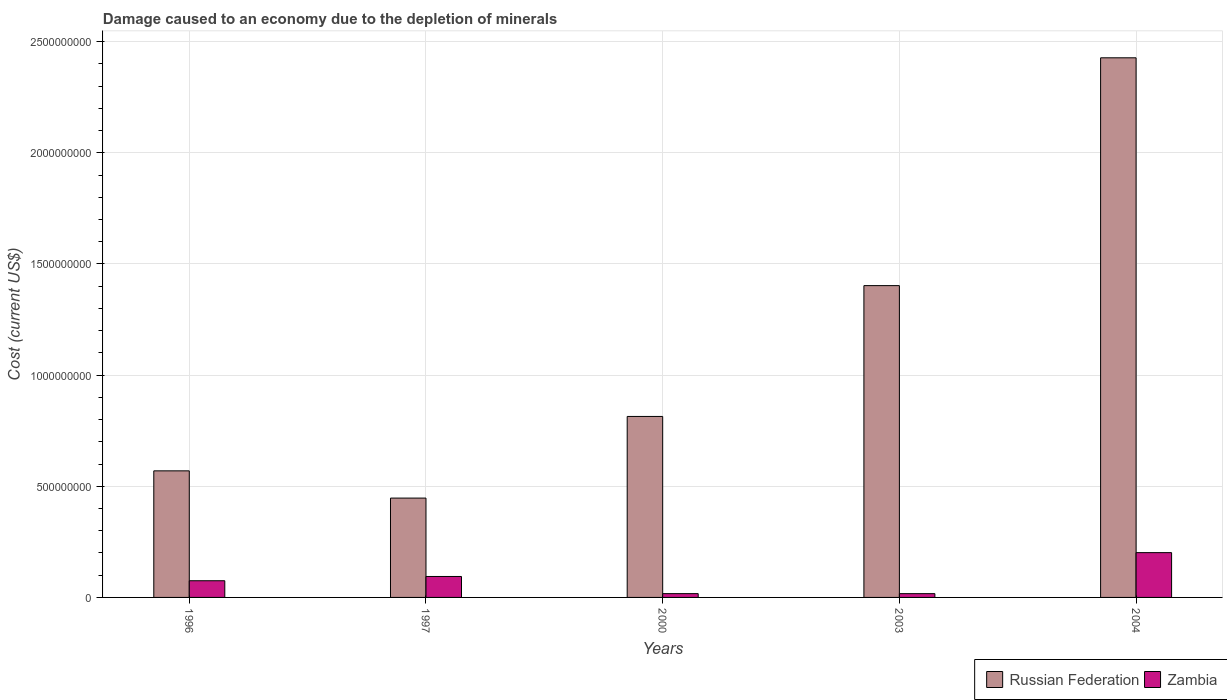How many groups of bars are there?
Offer a terse response. 5. Are the number of bars per tick equal to the number of legend labels?
Offer a terse response. Yes. How many bars are there on the 4th tick from the right?
Provide a succinct answer. 2. What is the label of the 2nd group of bars from the left?
Make the answer very short. 1997. What is the cost of damage caused due to the depletion of minerals in Russian Federation in 2004?
Make the answer very short. 2.43e+09. Across all years, what is the maximum cost of damage caused due to the depletion of minerals in Russian Federation?
Give a very brief answer. 2.43e+09. Across all years, what is the minimum cost of damage caused due to the depletion of minerals in Zambia?
Your answer should be very brief. 1.70e+07. In which year was the cost of damage caused due to the depletion of minerals in Zambia maximum?
Ensure brevity in your answer.  2004. What is the total cost of damage caused due to the depletion of minerals in Russian Federation in the graph?
Ensure brevity in your answer.  5.66e+09. What is the difference between the cost of damage caused due to the depletion of minerals in Zambia in 2003 and that in 2004?
Offer a terse response. -1.85e+08. What is the difference between the cost of damage caused due to the depletion of minerals in Russian Federation in 2000 and the cost of damage caused due to the depletion of minerals in Zambia in 2004?
Provide a succinct answer. 6.13e+08. What is the average cost of damage caused due to the depletion of minerals in Zambia per year?
Offer a terse response. 8.10e+07. In the year 2003, what is the difference between the cost of damage caused due to the depletion of minerals in Russian Federation and cost of damage caused due to the depletion of minerals in Zambia?
Your answer should be very brief. 1.39e+09. What is the ratio of the cost of damage caused due to the depletion of minerals in Zambia in 1996 to that in 1997?
Provide a succinct answer. 0.8. Is the difference between the cost of damage caused due to the depletion of minerals in Russian Federation in 1996 and 2003 greater than the difference between the cost of damage caused due to the depletion of minerals in Zambia in 1996 and 2003?
Offer a terse response. No. What is the difference between the highest and the second highest cost of damage caused due to the depletion of minerals in Zambia?
Your response must be concise. 1.07e+08. What is the difference between the highest and the lowest cost of damage caused due to the depletion of minerals in Russian Federation?
Your answer should be compact. 1.98e+09. What does the 2nd bar from the left in 2004 represents?
Make the answer very short. Zambia. What does the 2nd bar from the right in 1997 represents?
Give a very brief answer. Russian Federation. How many bars are there?
Ensure brevity in your answer.  10. How many years are there in the graph?
Your answer should be very brief. 5. What is the difference between two consecutive major ticks on the Y-axis?
Your answer should be compact. 5.00e+08. Are the values on the major ticks of Y-axis written in scientific E-notation?
Give a very brief answer. No. Does the graph contain any zero values?
Your answer should be very brief. No. Does the graph contain grids?
Your answer should be very brief. Yes. How many legend labels are there?
Offer a very short reply. 2. What is the title of the graph?
Offer a terse response. Damage caused to an economy due to the depletion of minerals. Does "Jamaica" appear as one of the legend labels in the graph?
Your answer should be very brief. No. What is the label or title of the X-axis?
Give a very brief answer. Years. What is the label or title of the Y-axis?
Your answer should be compact. Cost (current US$). What is the Cost (current US$) in Russian Federation in 1996?
Your answer should be very brief. 5.69e+08. What is the Cost (current US$) of Zambia in 1996?
Make the answer very short. 7.51e+07. What is the Cost (current US$) in Russian Federation in 1997?
Your answer should be compact. 4.47e+08. What is the Cost (current US$) in Zambia in 1997?
Offer a terse response. 9.42e+07. What is the Cost (current US$) of Russian Federation in 2000?
Your response must be concise. 8.14e+08. What is the Cost (current US$) of Zambia in 2000?
Provide a short and direct response. 1.70e+07. What is the Cost (current US$) of Russian Federation in 2003?
Make the answer very short. 1.40e+09. What is the Cost (current US$) of Zambia in 2003?
Offer a terse response. 1.70e+07. What is the Cost (current US$) in Russian Federation in 2004?
Your answer should be very brief. 2.43e+09. What is the Cost (current US$) in Zambia in 2004?
Provide a succinct answer. 2.02e+08. Across all years, what is the maximum Cost (current US$) in Russian Federation?
Make the answer very short. 2.43e+09. Across all years, what is the maximum Cost (current US$) in Zambia?
Make the answer very short. 2.02e+08. Across all years, what is the minimum Cost (current US$) in Russian Federation?
Give a very brief answer. 4.47e+08. Across all years, what is the minimum Cost (current US$) of Zambia?
Ensure brevity in your answer.  1.70e+07. What is the total Cost (current US$) of Russian Federation in the graph?
Ensure brevity in your answer.  5.66e+09. What is the total Cost (current US$) of Zambia in the graph?
Give a very brief answer. 4.05e+08. What is the difference between the Cost (current US$) of Russian Federation in 1996 and that in 1997?
Keep it short and to the point. 1.22e+08. What is the difference between the Cost (current US$) in Zambia in 1996 and that in 1997?
Give a very brief answer. -1.92e+07. What is the difference between the Cost (current US$) of Russian Federation in 1996 and that in 2000?
Your answer should be very brief. -2.45e+08. What is the difference between the Cost (current US$) in Zambia in 1996 and that in 2000?
Provide a short and direct response. 5.80e+07. What is the difference between the Cost (current US$) in Russian Federation in 1996 and that in 2003?
Your response must be concise. -8.33e+08. What is the difference between the Cost (current US$) in Zambia in 1996 and that in 2003?
Make the answer very short. 5.80e+07. What is the difference between the Cost (current US$) of Russian Federation in 1996 and that in 2004?
Ensure brevity in your answer.  -1.86e+09. What is the difference between the Cost (current US$) of Zambia in 1996 and that in 2004?
Offer a very short reply. -1.26e+08. What is the difference between the Cost (current US$) in Russian Federation in 1997 and that in 2000?
Keep it short and to the point. -3.67e+08. What is the difference between the Cost (current US$) of Zambia in 1997 and that in 2000?
Offer a very short reply. 7.72e+07. What is the difference between the Cost (current US$) in Russian Federation in 1997 and that in 2003?
Your answer should be compact. -9.56e+08. What is the difference between the Cost (current US$) of Zambia in 1997 and that in 2003?
Provide a succinct answer. 7.72e+07. What is the difference between the Cost (current US$) of Russian Federation in 1997 and that in 2004?
Your answer should be very brief. -1.98e+09. What is the difference between the Cost (current US$) of Zambia in 1997 and that in 2004?
Your answer should be compact. -1.07e+08. What is the difference between the Cost (current US$) of Russian Federation in 2000 and that in 2003?
Ensure brevity in your answer.  -5.88e+08. What is the difference between the Cost (current US$) in Zambia in 2000 and that in 2003?
Offer a very short reply. 1.23e+04. What is the difference between the Cost (current US$) of Russian Federation in 2000 and that in 2004?
Your answer should be very brief. -1.61e+09. What is the difference between the Cost (current US$) in Zambia in 2000 and that in 2004?
Keep it short and to the point. -1.84e+08. What is the difference between the Cost (current US$) of Russian Federation in 2003 and that in 2004?
Keep it short and to the point. -1.02e+09. What is the difference between the Cost (current US$) of Zambia in 2003 and that in 2004?
Offer a terse response. -1.85e+08. What is the difference between the Cost (current US$) of Russian Federation in 1996 and the Cost (current US$) of Zambia in 1997?
Your response must be concise. 4.75e+08. What is the difference between the Cost (current US$) of Russian Federation in 1996 and the Cost (current US$) of Zambia in 2000?
Give a very brief answer. 5.52e+08. What is the difference between the Cost (current US$) of Russian Federation in 1996 and the Cost (current US$) of Zambia in 2003?
Provide a succinct answer. 5.52e+08. What is the difference between the Cost (current US$) in Russian Federation in 1996 and the Cost (current US$) in Zambia in 2004?
Give a very brief answer. 3.68e+08. What is the difference between the Cost (current US$) of Russian Federation in 1997 and the Cost (current US$) of Zambia in 2000?
Keep it short and to the point. 4.30e+08. What is the difference between the Cost (current US$) of Russian Federation in 1997 and the Cost (current US$) of Zambia in 2003?
Offer a terse response. 4.30e+08. What is the difference between the Cost (current US$) in Russian Federation in 1997 and the Cost (current US$) in Zambia in 2004?
Keep it short and to the point. 2.45e+08. What is the difference between the Cost (current US$) in Russian Federation in 2000 and the Cost (current US$) in Zambia in 2003?
Provide a succinct answer. 7.97e+08. What is the difference between the Cost (current US$) of Russian Federation in 2000 and the Cost (current US$) of Zambia in 2004?
Your answer should be compact. 6.13e+08. What is the difference between the Cost (current US$) of Russian Federation in 2003 and the Cost (current US$) of Zambia in 2004?
Make the answer very short. 1.20e+09. What is the average Cost (current US$) of Russian Federation per year?
Make the answer very short. 1.13e+09. What is the average Cost (current US$) in Zambia per year?
Make the answer very short. 8.10e+07. In the year 1996, what is the difference between the Cost (current US$) of Russian Federation and Cost (current US$) of Zambia?
Give a very brief answer. 4.94e+08. In the year 1997, what is the difference between the Cost (current US$) of Russian Federation and Cost (current US$) of Zambia?
Offer a very short reply. 3.53e+08. In the year 2000, what is the difference between the Cost (current US$) of Russian Federation and Cost (current US$) of Zambia?
Keep it short and to the point. 7.97e+08. In the year 2003, what is the difference between the Cost (current US$) of Russian Federation and Cost (current US$) of Zambia?
Give a very brief answer. 1.39e+09. In the year 2004, what is the difference between the Cost (current US$) in Russian Federation and Cost (current US$) in Zambia?
Provide a short and direct response. 2.23e+09. What is the ratio of the Cost (current US$) in Russian Federation in 1996 to that in 1997?
Ensure brevity in your answer.  1.27. What is the ratio of the Cost (current US$) of Zambia in 1996 to that in 1997?
Ensure brevity in your answer.  0.8. What is the ratio of the Cost (current US$) of Russian Federation in 1996 to that in 2000?
Provide a short and direct response. 0.7. What is the ratio of the Cost (current US$) in Zambia in 1996 to that in 2000?
Ensure brevity in your answer.  4.4. What is the ratio of the Cost (current US$) of Russian Federation in 1996 to that in 2003?
Your response must be concise. 0.41. What is the ratio of the Cost (current US$) in Zambia in 1996 to that in 2003?
Keep it short and to the point. 4.41. What is the ratio of the Cost (current US$) of Russian Federation in 1996 to that in 2004?
Provide a succinct answer. 0.23. What is the ratio of the Cost (current US$) of Zambia in 1996 to that in 2004?
Keep it short and to the point. 0.37. What is the ratio of the Cost (current US$) of Russian Federation in 1997 to that in 2000?
Your answer should be very brief. 0.55. What is the ratio of the Cost (current US$) in Zambia in 1997 to that in 2000?
Ensure brevity in your answer.  5.53. What is the ratio of the Cost (current US$) of Russian Federation in 1997 to that in 2003?
Keep it short and to the point. 0.32. What is the ratio of the Cost (current US$) of Zambia in 1997 to that in 2003?
Your response must be concise. 5.53. What is the ratio of the Cost (current US$) in Russian Federation in 1997 to that in 2004?
Give a very brief answer. 0.18. What is the ratio of the Cost (current US$) in Zambia in 1997 to that in 2004?
Give a very brief answer. 0.47. What is the ratio of the Cost (current US$) of Russian Federation in 2000 to that in 2003?
Offer a very short reply. 0.58. What is the ratio of the Cost (current US$) in Zambia in 2000 to that in 2003?
Offer a terse response. 1. What is the ratio of the Cost (current US$) in Russian Federation in 2000 to that in 2004?
Make the answer very short. 0.34. What is the ratio of the Cost (current US$) of Zambia in 2000 to that in 2004?
Ensure brevity in your answer.  0.08. What is the ratio of the Cost (current US$) of Russian Federation in 2003 to that in 2004?
Provide a succinct answer. 0.58. What is the ratio of the Cost (current US$) in Zambia in 2003 to that in 2004?
Your answer should be very brief. 0.08. What is the difference between the highest and the second highest Cost (current US$) of Russian Federation?
Your response must be concise. 1.02e+09. What is the difference between the highest and the second highest Cost (current US$) of Zambia?
Ensure brevity in your answer.  1.07e+08. What is the difference between the highest and the lowest Cost (current US$) in Russian Federation?
Make the answer very short. 1.98e+09. What is the difference between the highest and the lowest Cost (current US$) of Zambia?
Your answer should be compact. 1.85e+08. 